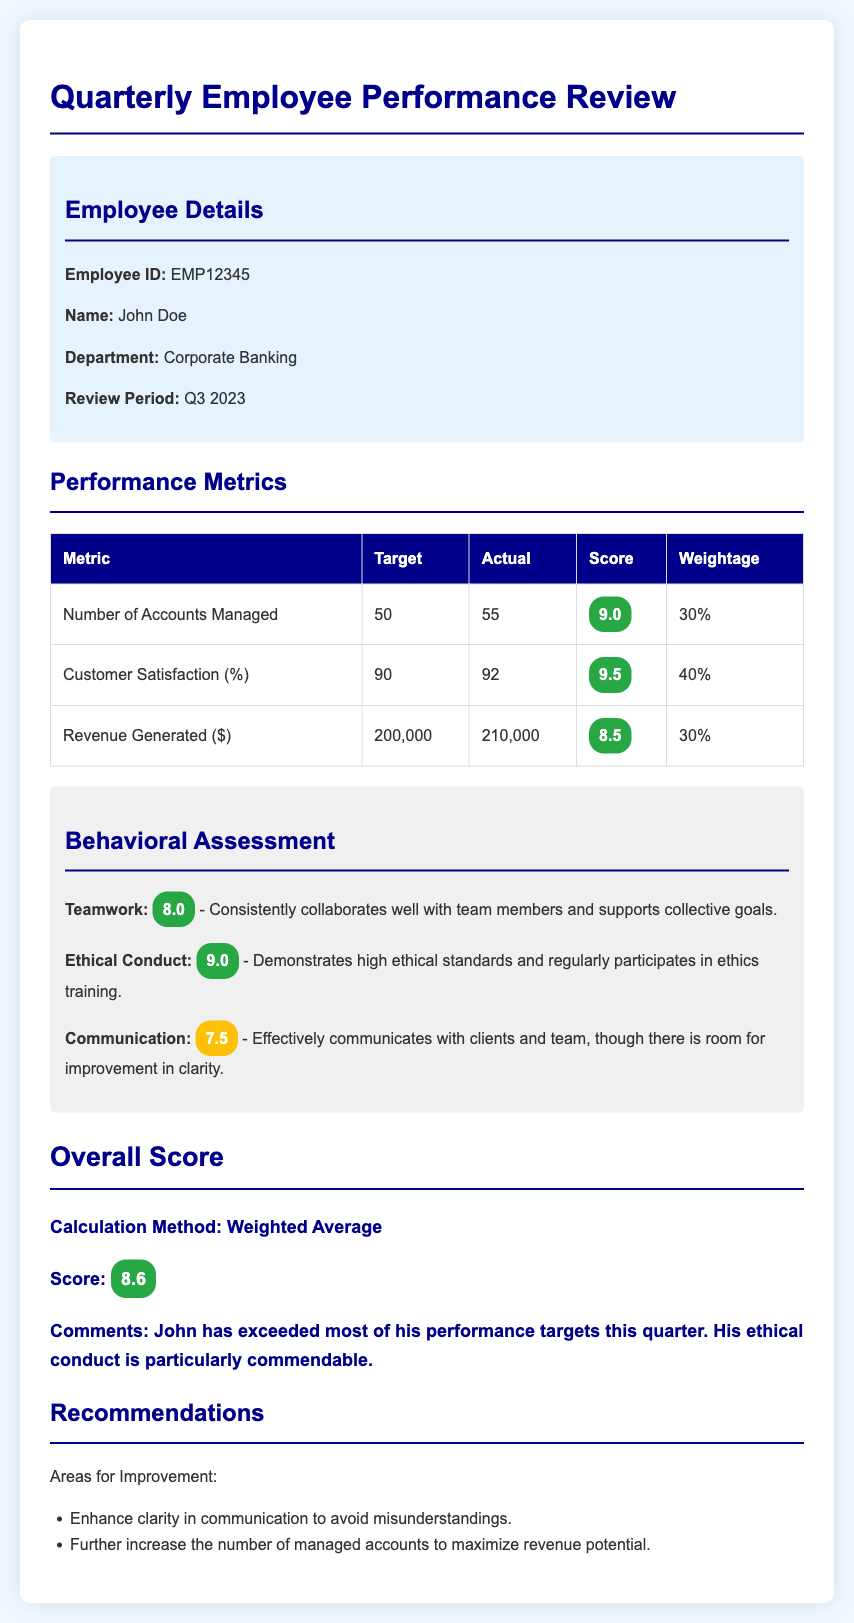What is the employee's name? The employee's name is stated in the employee details section of the document.
Answer: John Doe What was the target number of accounts managed? The target number of accounts managed is listed under the performance metrics section.
Answer: 50 What was the actual customer satisfaction percentage? The actual customer satisfaction percentage can be found in the performance metrics table.
Answer: 92 What is the score for ethical conduct? The score for ethical conduct is provided in the behavioral assessment section.
Answer: 9.0 What is the overall score for the employee? The overall score is mentioned in the overall score section of the document.
Answer: 8.6 What is one recommendation for improvement? Recommendations for improvement are listed in the recommendations section.
Answer: Enhance clarity in communication to avoid misunderstandings Which department does the employee work in? The department is mentioned in the employee details section.
Answer: Corporate Banking What is the weightage for customer satisfaction? The weightage for customer satisfaction is specified in the performance metrics table.
Answer: 40% What period is being reviewed? The review period is indicated in the employee details section.
Answer: Q3 2023 